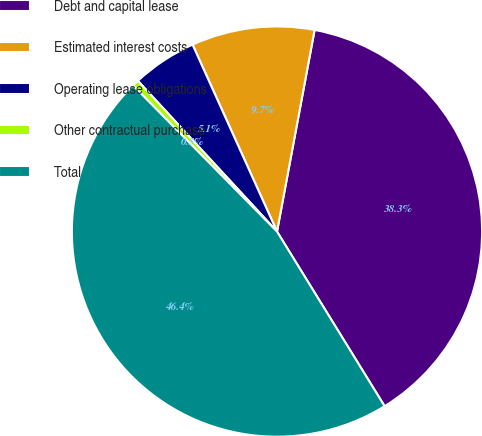Convert chart to OTSL. <chart><loc_0><loc_0><loc_500><loc_500><pie_chart><fcel>Debt and capital lease<fcel>Estimated interest costs<fcel>Operating lease obligations<fcel>Other contractual purchase<fcel>Total<nl><fcel>38.28%<fcel>9.69%<fcel>5.11%<fcel>0.52%<fcel>46.41%<nl></chart> 